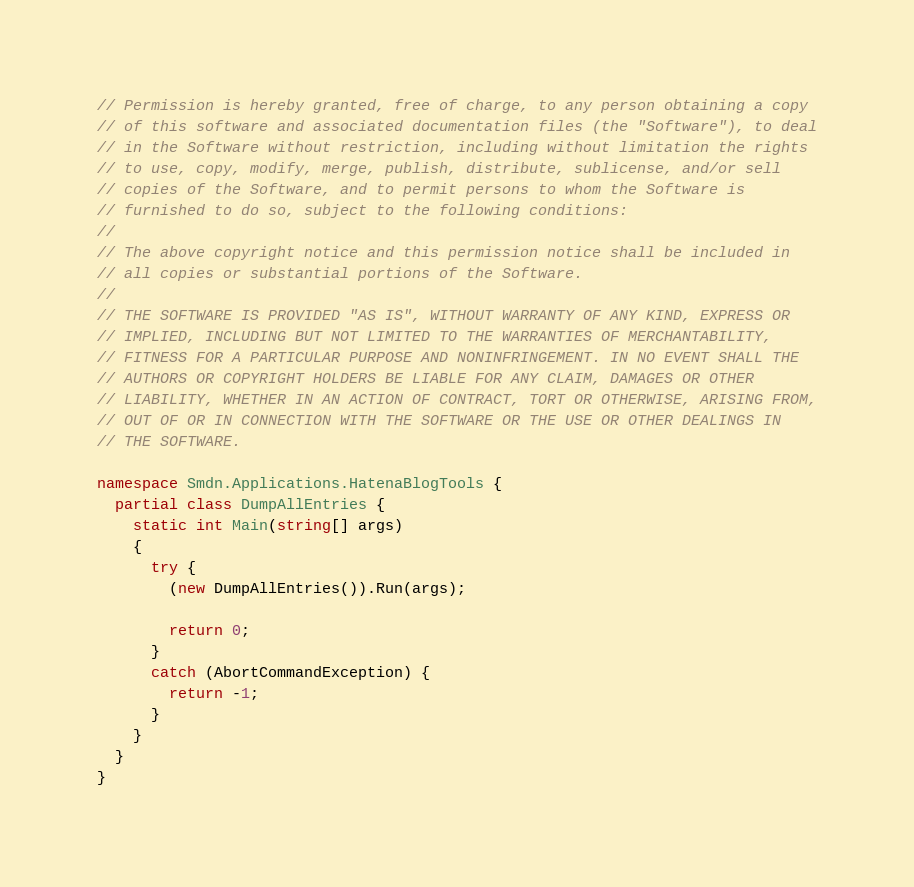Convert code to text. <code><loc_0><loc_0><loc_500><loc_500><_C#_>// Permission is hereby granted, free of charge, to any person obtaining a copy
// of this software and associated documentation files (the "Software"), to deal
// in the Software without restriction, including without limitation the rights
// to use, copy, modify, merge, publish, distribute, sublicense, and/or sell
// copies of the Software, and to permit persons to whom the Software is
// furnished to do so, subject to the following conditions:
//
// The above copyright notice and this permission notice shall be included in
// all copies or substantial portions of the Software.
//
// THE SOFTWARE IS PROVIDED "AS IS", WITHOUT WARRANTY OF ANY KIND, EXPRESS OR
// IMPLIED, INCLUDING BUT NOT LIMITED TO THE WARRANTIES OF MERCHANTABILITY,
// FITNESS FOR A PARTICULAR PURPOSE AND NONINFRINGEMENT. IN NO EVENT SHALL THE
// AUTHORS OR COPYRIGHT HOLDERS BE LIABLE FOR ANY CLAIM, DAMAGES OR OTHER
// LIABILITY, WHETHER IN AN ACTION OF CONTRACT, TORT OR OTHERWISE, ARISING FROM,
// OUT OF OR IN CONNECTION WITH THE SOFTWARE OR THE USE OR OTHER DEALINGS IN
// THE SOFTWARE.

namespace Smdn.Applications.HatenaBlogTools {
  partial class DumpAllEntries {
    static int Main(string[] args)
    {
      try {
        (new DumpAllEntries()).Run(args);

        return 0;
      }
      catch (AbortCommandException) {
        return -1;
      }
    }
  }
}
</code> 